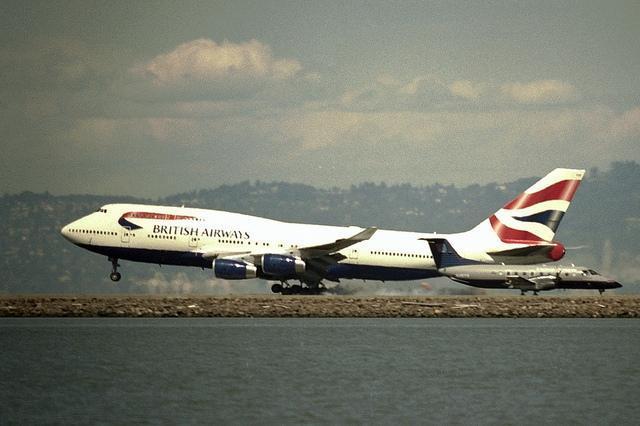How many airplanes are there?
Give a very brief answer. 2. 